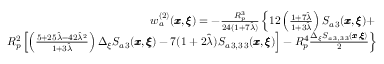<formula> <loc_0><loc_0><loc_500><loc_500>\begin{array} { r l r } & { w _ { a } ^ { ( 2 ) } ( { \pm b x } , { \pm b \xi } ) = - \frac { R _ { p } ^ { 3 } } { 2 4 ( 1 + 7 \hat { \lambda } ) } \left \{ 1 2 \left ( \frac { 1 + 7 \hat { \lambda } } { 1 + 3 \hat { \lambda } } \right ) S _ { a \, 3 } ( { \pm b x } , { \pm b \xi } ) + } \\ & { { R _ { p } ^ { 2 } } \left [ \left ( \frac { 5 + 2 5 \hat { \lambda } - 4 2 \hat { \lambda } ^ { 2 } } { 1 + 3 \hat { \lambda } } \right ) \Delta _ { \xi } S _ { a \, 3 } ( { \pm b x } , { \pm b \xi } ) - 7 ( 1 + 2 \hat { \lambda } ) S _ { a \, 3 , 3 \, 3 } ( { \pm b x } , { \pm b \xi } ) \right ] - R _ { p } ^ { 4 } \frac { \Delta _ { \xi } S _ { a \, 3 , 3 \, 3 } ( { \pm b x } , { \pm b \xi } ) } { 2 } \right \} } \end{array}</formula> 